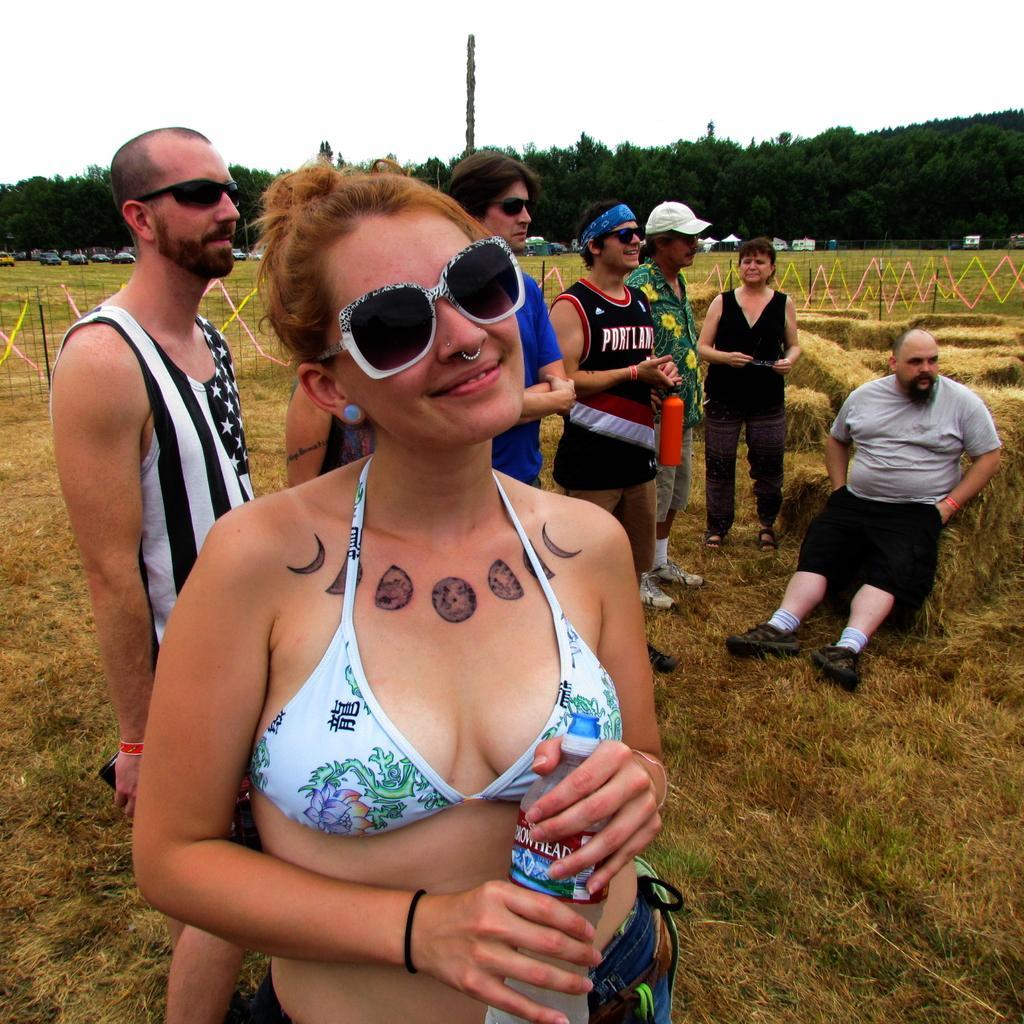Could you give a brief overview of what you see in this image? In this image I can see there are few persons standing on grass and some of them holding bottles and a person sitting on grass at the top I can see the sky and in the middle I can see a fence. 